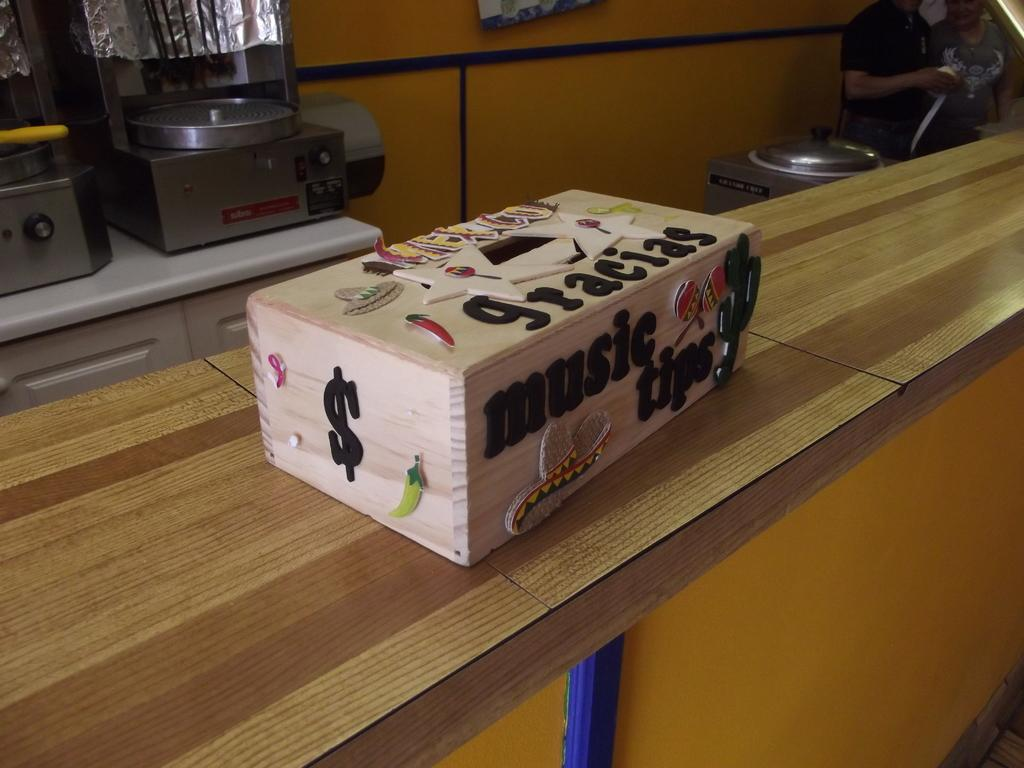<image>
Render a clear and concise summary of the photo. A wood music tips box with a $ on the side. 